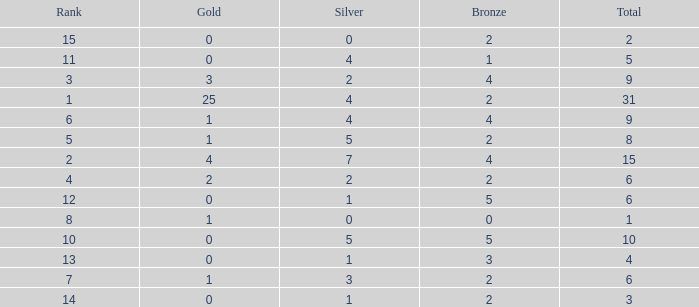What is the highest rank of the medal total less than 15, more than 2 bronzes, 0 gold and 1 silver? 13.0. 